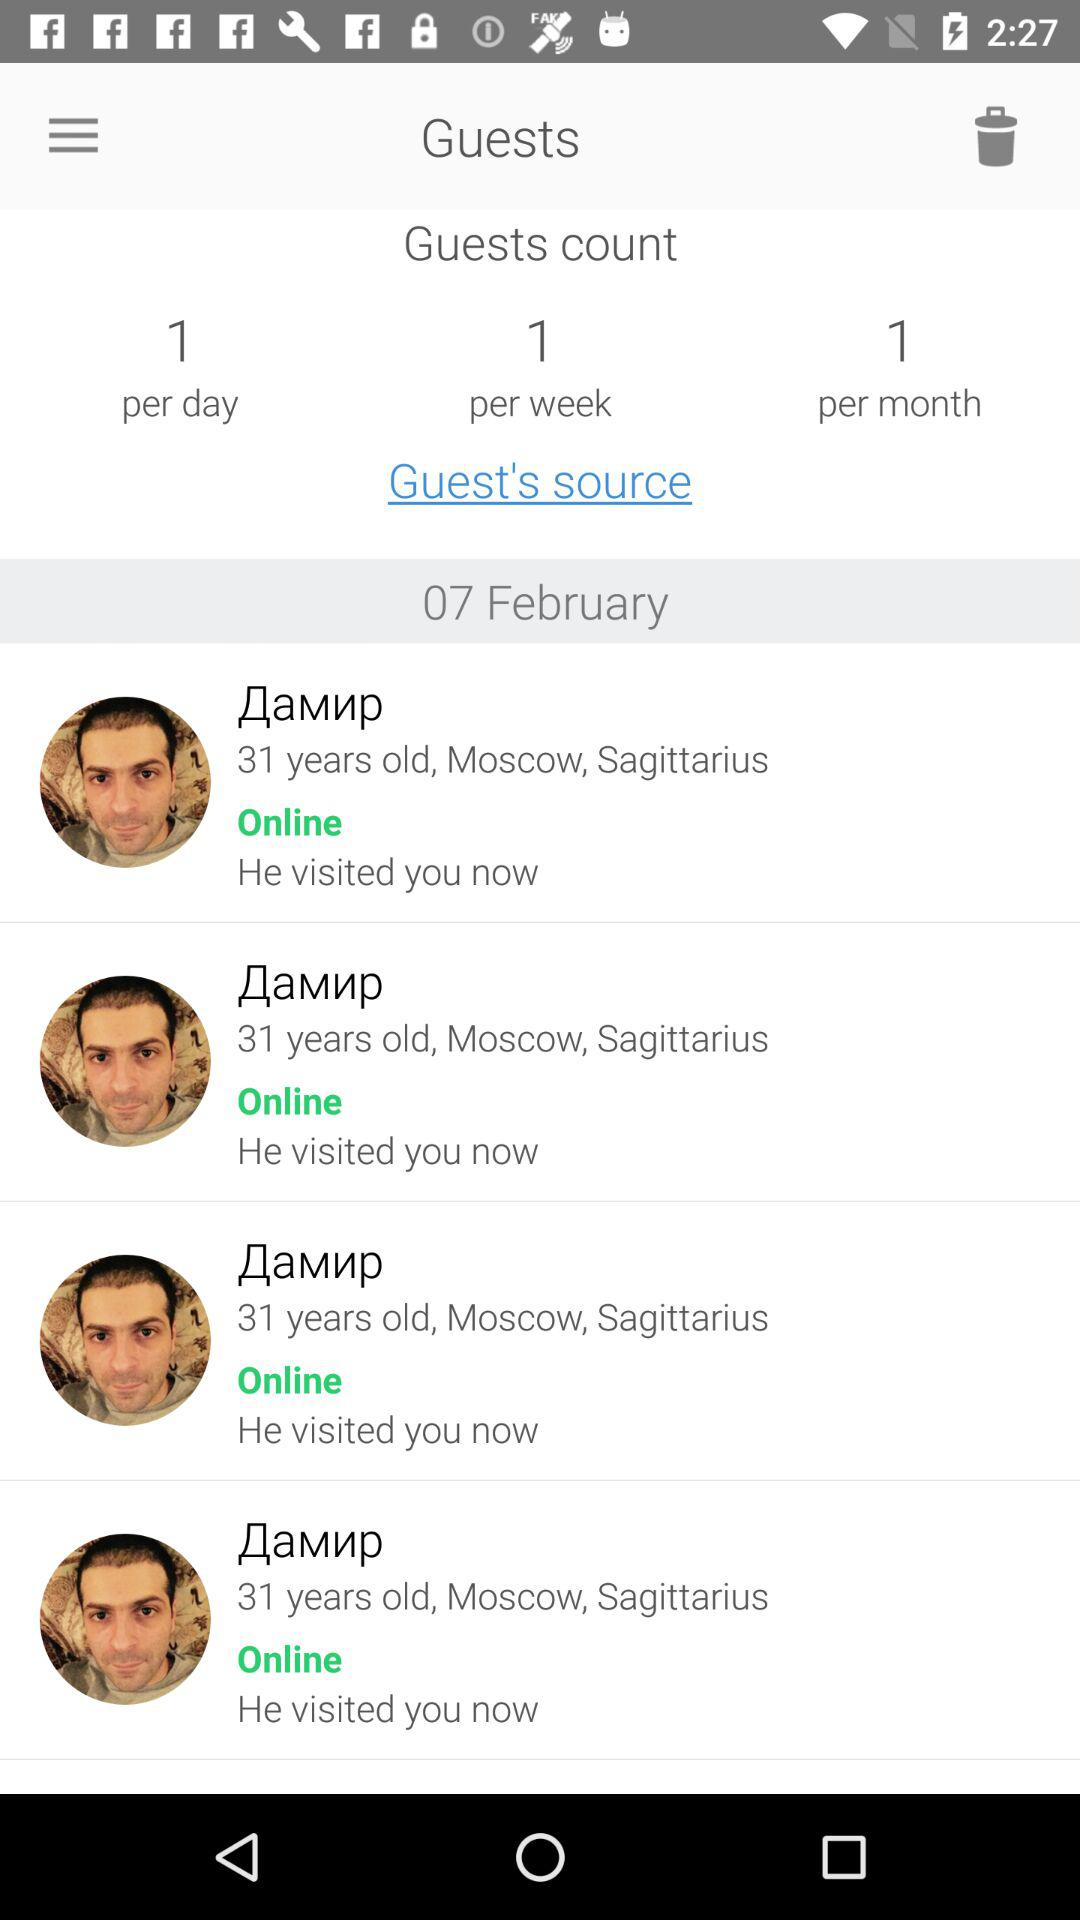What is the per-day guest count? The per-day guest count is 1. 